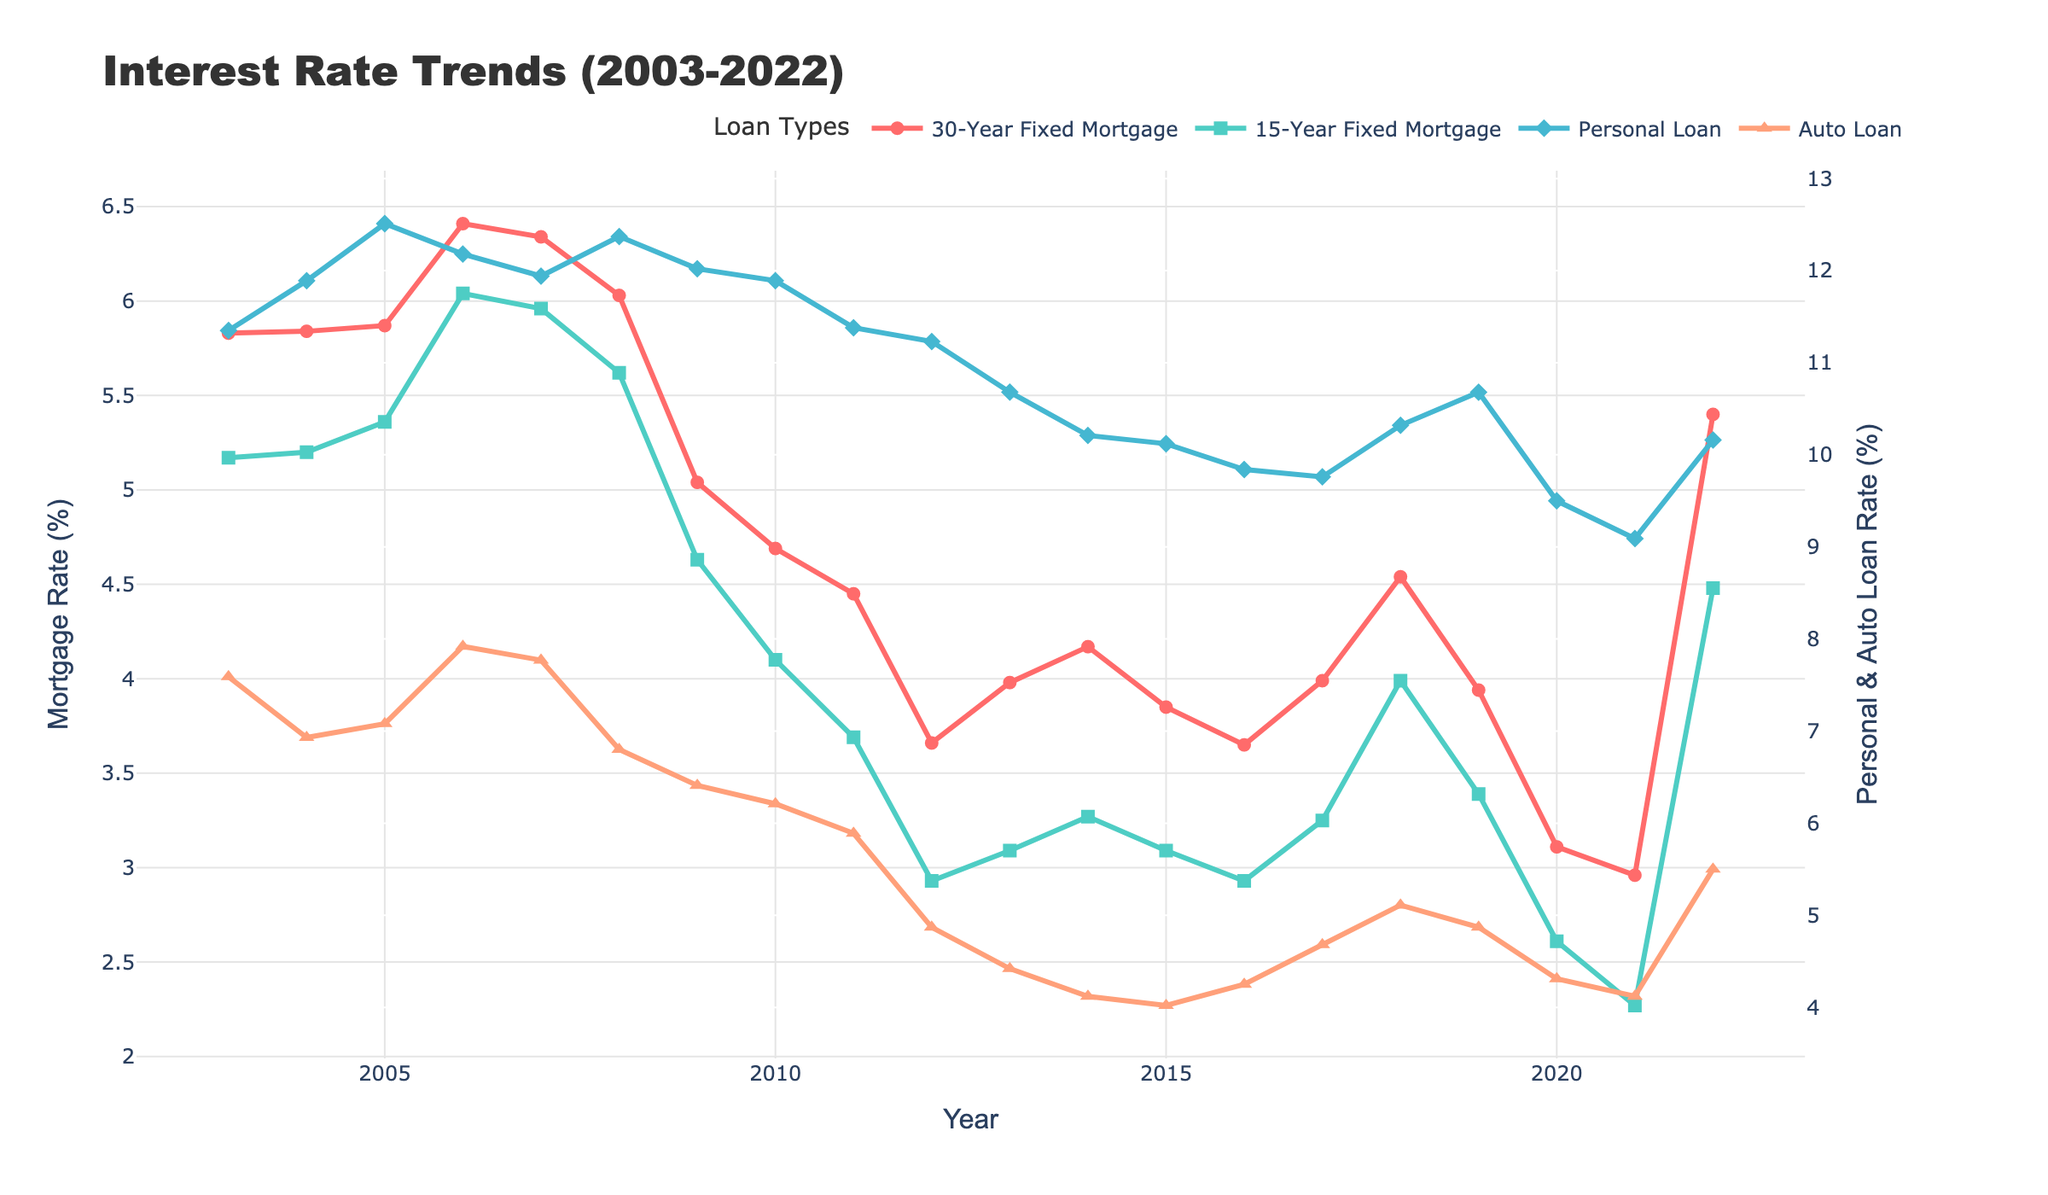What loan type had the highest interest rate in 2022? Examine the chart for the year 2022 and look at the interest rates for all the loan types; the Personal Loan rate is the highest.
Answer: Personal Loan Between 2008 and 2012, did the interest rate for Auto Loans ever fall below 5%? Check the Auto Loan interest rate curve between 2008 and 2012; it stays above 5% during these years.
Answer: No Which year had the lowest 15-Year Fixed Mortgage rate and what was it? Find the minimum point on the 15-Year Fixed Mortgage curve and note the year and the rate; it is 2012 at 2.93%.
Answer: 2012, 2.93% Compare the interest rates of 30-Year Fixed Mortgage and Personal Loan in 2010. Which one is higher and by how much? Look at the rates for these two loan types in 2010; 30-Year Fixed Mortgage is 4.69% and Personal Loan is 11.89%. The difference is 11.89 - 4.69 = 7.20%.
Answer: Personal Loan by 7.20% Which loan type showed the most stable interest rates from 2003 to 2022? Observe the fluctuations of each loan type's interest rate curve; the 30-Year Fixed Mortgage shows the smallest variation in this period.
Answer: 30-Year Fixed Mortgage In which year was the difference between the 30-Year Fixed Mortgage rate and the 15-Year Fixed Mortgage rate the smallest? Calculate the differences year by year and find the minimum value; it is smallest in 2021 where the difference is 2.96 - 2.27 = 0.69%.
Answer: 2021 What was the average interest rate for Auto Loans from 2015 to 2020? Sum the Auto Loan rates for the years 2015, 2016, 2017, 2018, 2019, and 2020, then divide by the number of years; (4.02 + 4.25 + 4.68 + 5.11 + 4.87 + 4.31) / 6 = 4.54%.
Answer: 4.54% Did the interest rate for Personal Loans ever exceed 12%? If so, in which years? Look for points on the Personal Loan curve that exceed 12%; it happened in 2004, 2005, 2006, and 2008.
Answer: 2004, 2005, 2006, 2008 Which two loan types had the closest interest rates in 2020 and what were those rates? Compare the interest rates for all loan types in 2020; Personal Loan (9.50%) and Auto Loan (4.31%) are closest compared to others.
Answer: Personal Loan: 9.50%, Auto Loan: 4.31% How did the interest rate trend for the 30-Year Fixed Mortgage correlate to the trend for the 15-Year Fixed Mortgage over the 20 years? Examine the trends of both lines; both trends generally follow a similar pattern, rising and falling together, indicating a positive correlation.
Answer: Positive correlation 